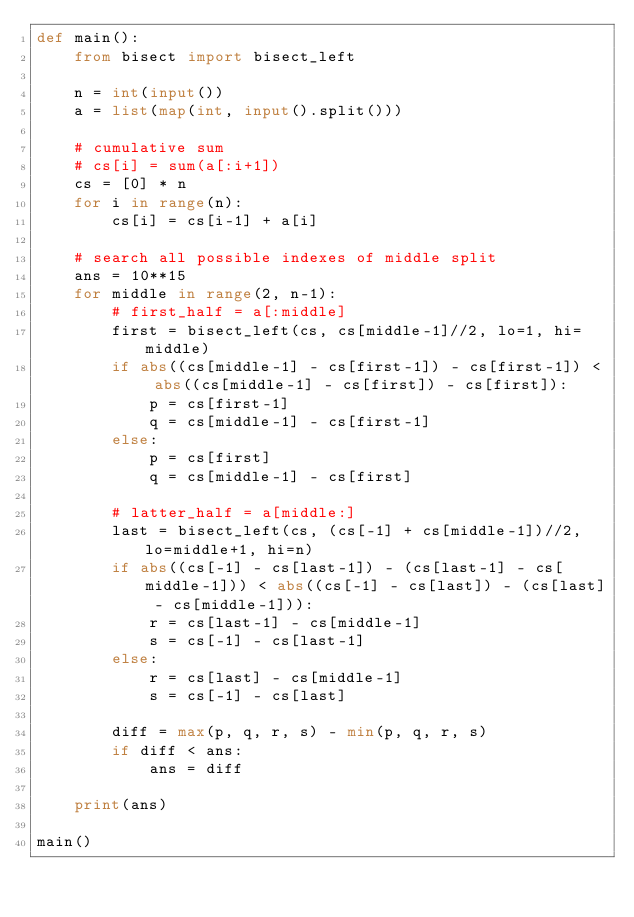<code> <loc_0><loc_0><loc_500><loc_500><_Python_>def main():
    from bisect import bisect_left

    n = int(input())
    a = list(map(int, input().split()))

    # cumulative sum
    # cs[i] = sum(a[:i+1])
    cs = [0] * n
    for i in range(n):
        cs[i] = cs[i-1] + a[i]

    # search all possible indexes of middle split
    ans = 10**15
    for middle in range(2, n-1):
        # first_half = a[:middle]
        first = bisect_left(cs, cs[middle-1]//2, lo=1, hi=middle)
        if abs((cs[middle-1] - cs[first-1]) - cs[first-1]) < abs((cs[middle-1] - cs[first]) - cs[first]):
            p = cs[first-1]
            q = cs[middle-1] - cs[first-1]
        else:
            p = cs[first]
            q = cs[middle-1] - cs[first]

        # latter_half = a[middle:]
        last = bisect_left(cs, (cs[-1] + cs[middle-1])//2, lo=middle+1, hi=n)
        if abs((cs[-1] - cs[last-1]) - (cs[last-1] - cs[middle-1])) < abs((cs[-1] - cs[last]) - (cs[last] - cs[middle-1])):
            r = cs[last-1] - cs[middle-1]
            s = cs[-1] - cs[last-1]
        else:
            r = cs[last] - cs[middle-1]
            s = cs[-1] - cs[last]
        
        diff = max(p, q, r, s) - min(p, q, r, s)
        if diff < ans:
            ans = diff
    
    print(ans)

main()</code> 